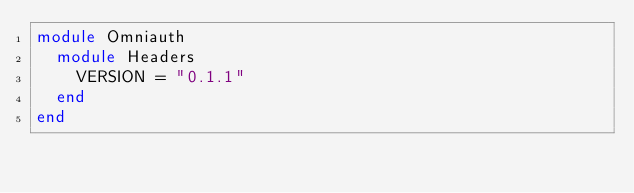Convert code to text. <code><loc_0><loc_0><loc_500><loc_500><_Ruby_>module Omniauth
  module Headers
    VERSION = "0.1.1"
  end
end
</code> 